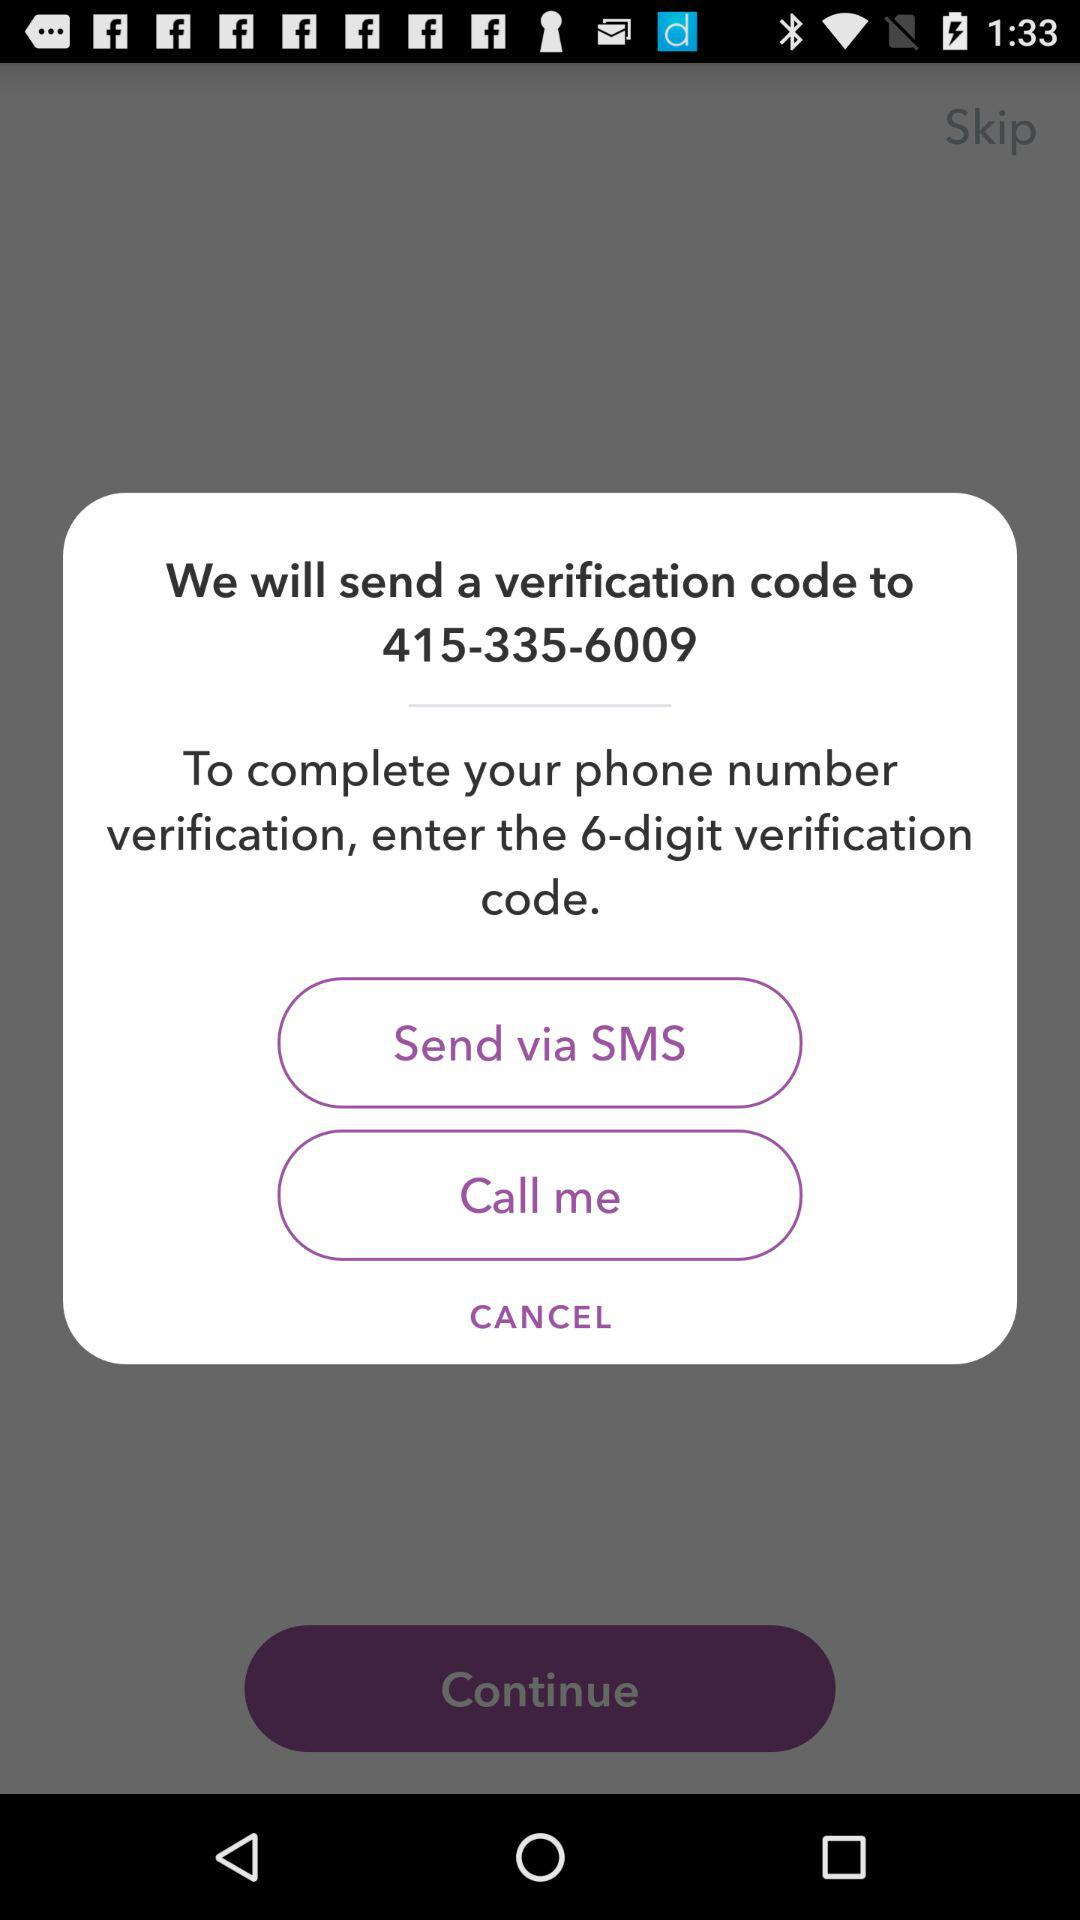How many digits are in the verification code?
Answer the question using a single word or phrase. 6 